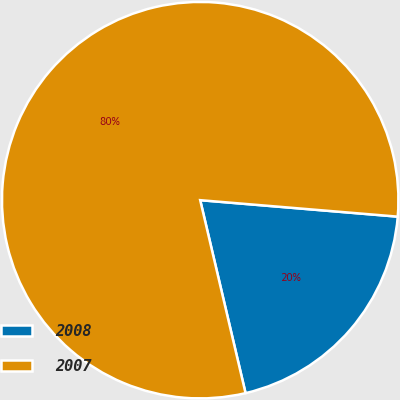Convert chart. <chart><loc_0><loc_0><loc_500><loc_500><pie_chart><fcel>2008<fcel>2007<nl><fcel>20.0%<fcel>80.0%<nl></chart> 